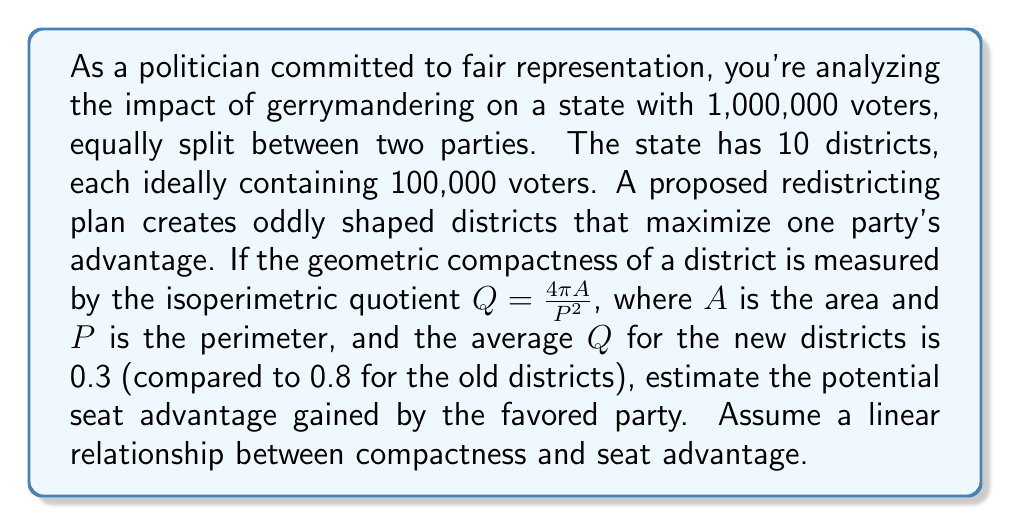Help me with this question. Let's approach this step-by-step:

1) The isoperimetric quotient $Q = \frac{4\pi A}{P^2}$ measures how close a shape is to a perfect circle (which has $Q = 1$). Lower values indicate less compact, more gerrymandered districts.

2) We're given:
   - Old districts' average $Q = 0.8$
   - New districts' average $Q = 0.3$

3) The decrease in compactness is:
   $\Delta Q = 0.8 - 0.3 = 0.5$

4) To estimate the seat advantage, we need to consider the maximum possible advantage. In a perfectly gerrymandered scenario, one party could theoretically win 9 out of 10 seats with just over 50% of the vote.

5) Let's assume a linear relationship between the decrease in compactness and the seat advantage, with a maximum of 4 seats (going from 5-5 to 9-1).

6) We can set up a proportion:
   $$\frac{\text{Seat advantage}}{\text{Maximum advantage}} = \frac{\Delta Q}{\text{Maximum } \Delta Q}$$

7) The maximum $\Delta Q$ would be from 1 (perfect circle) to 0 (theoretical limit), so 1.

8) Plugging in our values:
   $$\frac{\text{Seat advantage}}{4} = \frac{0.5}{1}$$

9) Solving for seat advantage:
   $$\text{Seat advantage} = 4 \times 0.5 = 2$$

Therefore, the estimated seat advantage is 2 seats.
Answer: The potential seat advantage gained by the favored party is estimated to be 2 seats. 